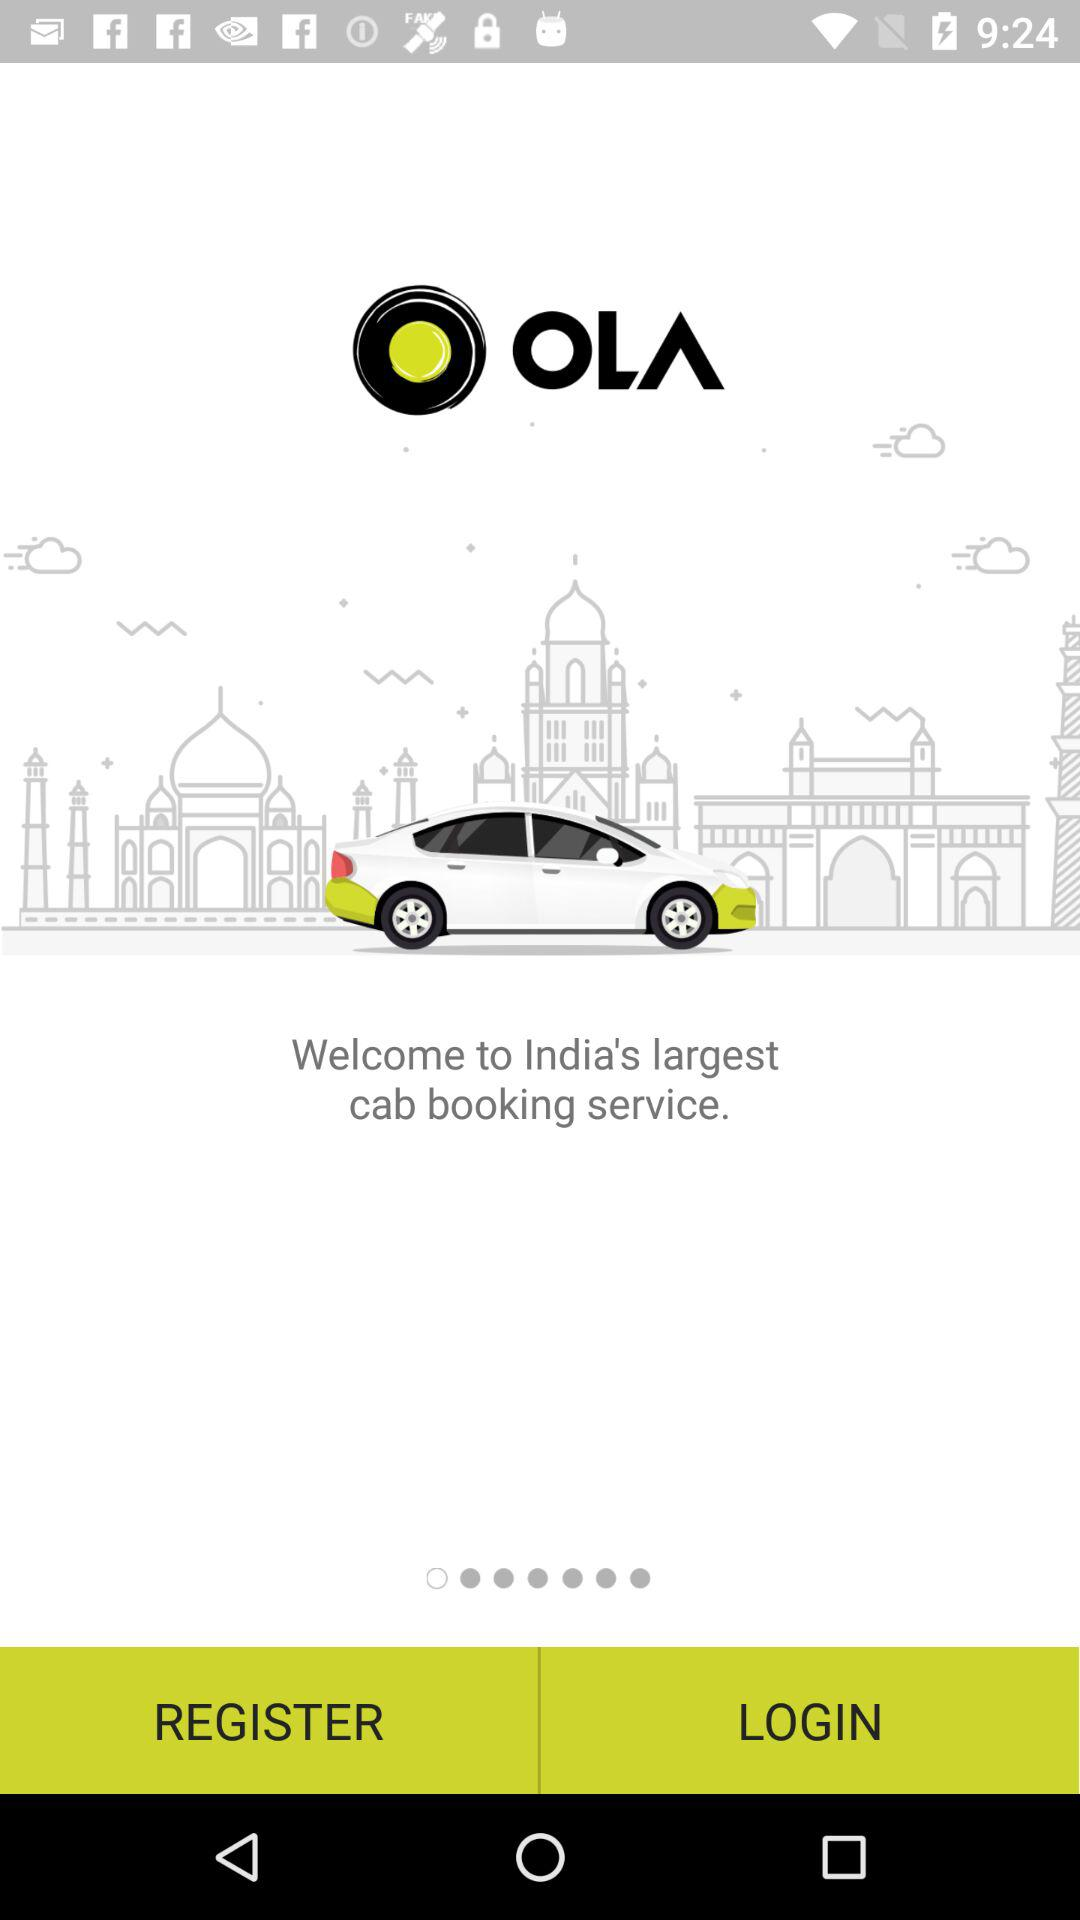What is the application Name? The application name is "OLA". 